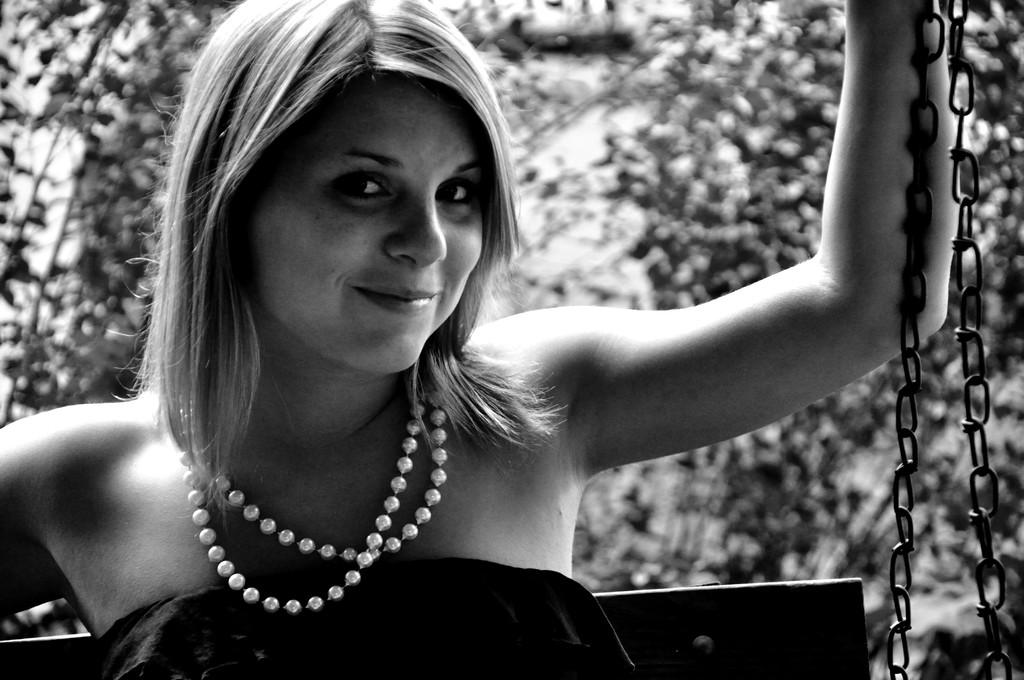Who is present in the image? There is a woman in the image. What is the woman holding in the image? The woman is holding chains. What can be seen in the distance behind the woman? There are trees visible in the background of the image. What color are the woman's trousers in the image? The provided facts do not mention the color or type of clothing the woman is wearing, so we cannot determine the color of her trousers. 